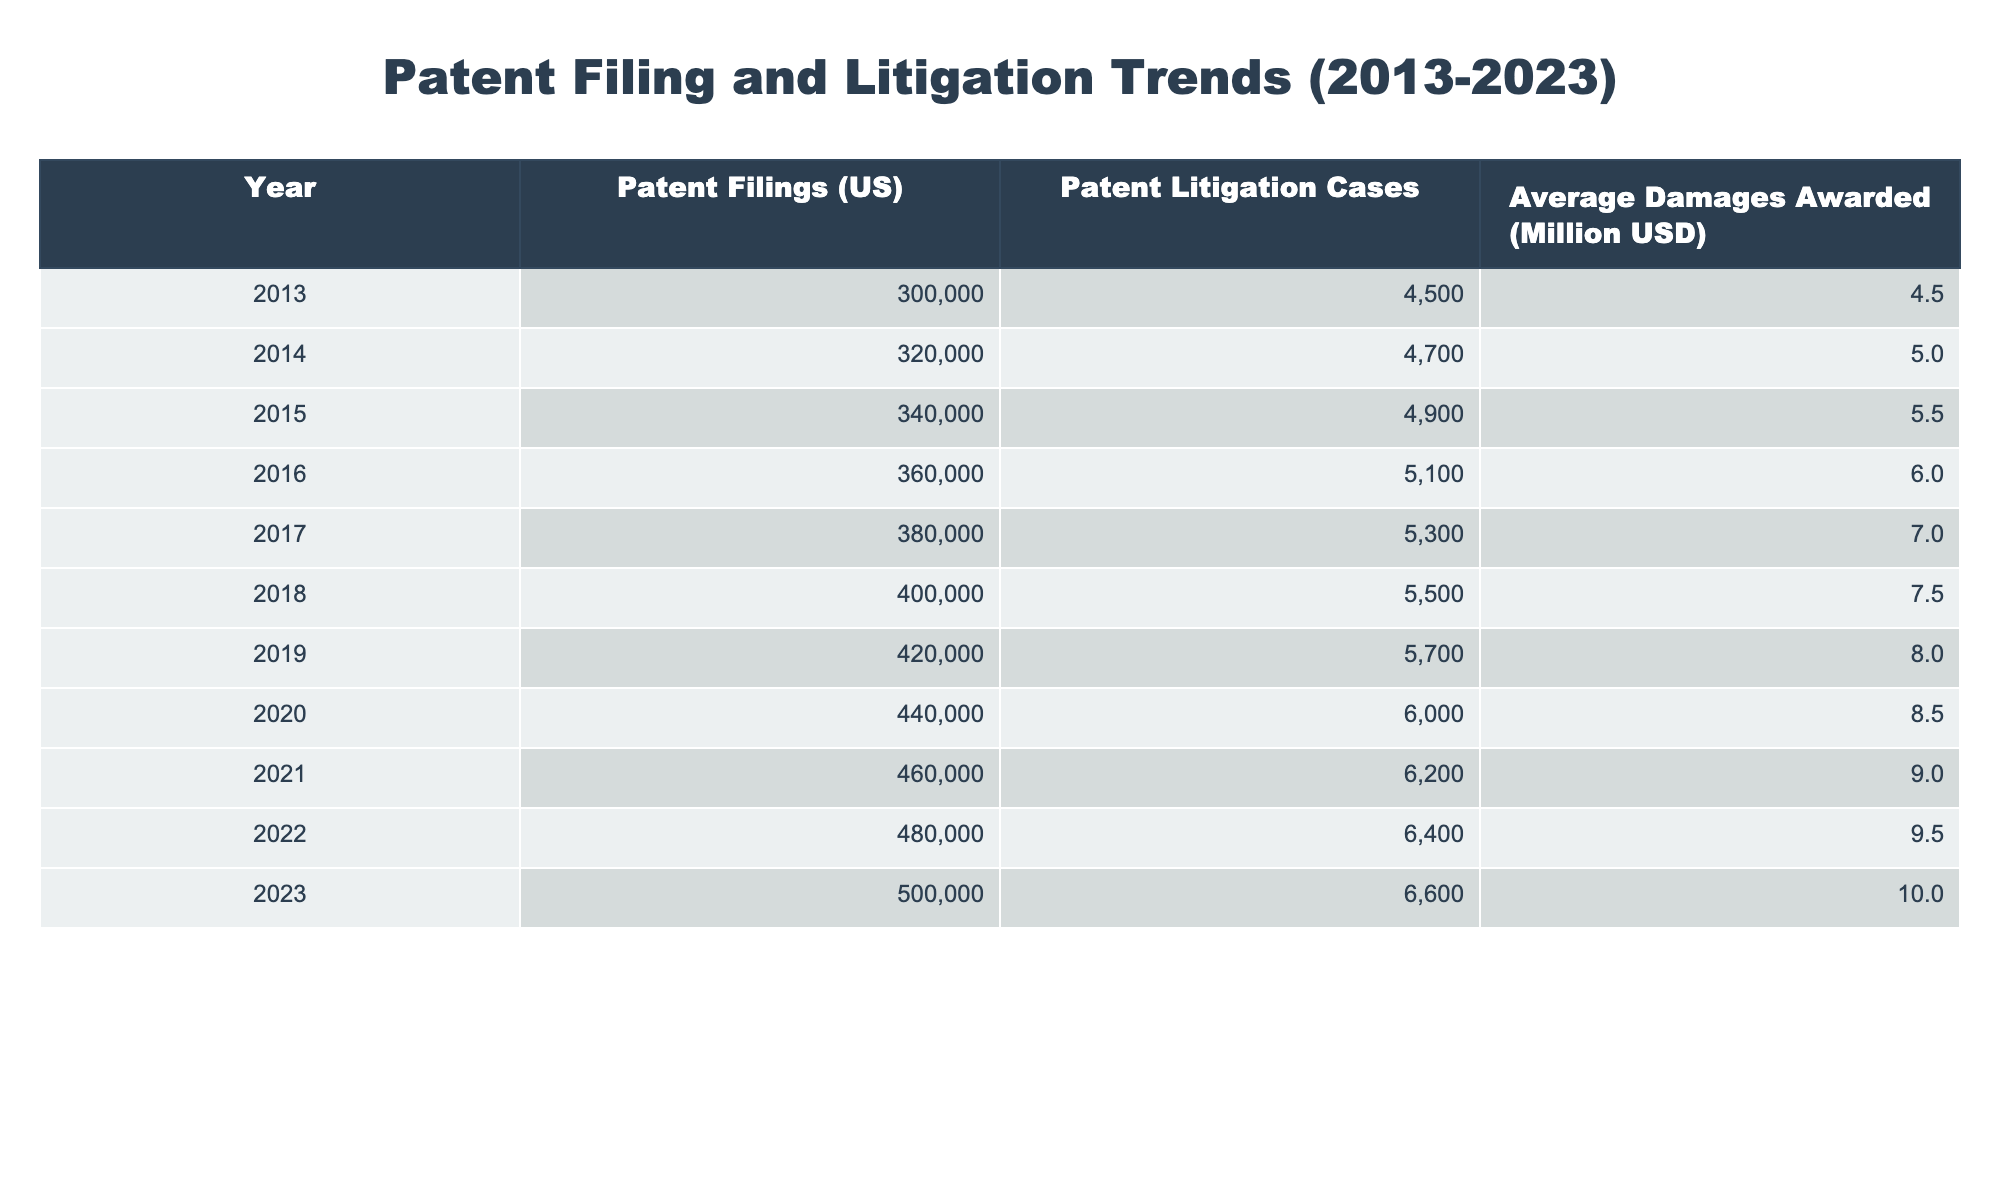What year saw the highest number of patent filings? By looking at the table, the 'Patent Filings (US)' column shows the values for each year. The highest value is 500,000 in the year 2023.
Answer: 2023 What was the average damages awarded in 2018? The table provides the 'Average Damages Awarded' for the year 2018 directly, which is listed as 7.5 million USD.
Answer: 7.5 million USD How many more patent litigation cases were there in 2020 compared to 2015? In 2020, there were 6,000 litigation cases, and in 2015, there were 4,900 cases. The difference is calculated as 6,000 - 4,900 = 1,100.
Answer: 1,100 Did the average damages awarded increase every year? The table shows a consistent increase in the 'Average Damages Awarded' from 4.5 million USD in 2013 to 10 million USD in 2023, indicating a yearly increase.
Answer: Yes What was the total number of patent filings from 2013 to 2022? To find the total, add the number of patent filings for each year from 2013 (300,000) to 2022 (480,000). The total is 300,000 + 320,000 + 340,000 + 360,000 + 380,000 + 400,000 + 420,000 + 440,000 + 460,000 + 480,000 =  3,460,000.
Answer: 3,460,000 What is the average number of patent litigation cases from 2013 to 2023? The sum of patent litigation cases from each year is 4500 + 4700 + 4900 + 5100 + 5300 + 5500 + 5700 + 6000 + 6200 + 6400 + 6600 =  56,600. There are 11 years, so the average is 56,600 / 11 = 5,145.45.
Answer: Approximately 5,145 Which year had the largest increase in the average damages awarded? To find this, look at the differences in 'Average Damages Awarded' between consecutive years. The largest increase was from 9.5 million USD in 2022 to 10 million USD in 2023, which is an increase of 0.5 million USD.
Answer: 2022 to 2023 How many total patent litigation cases occurred in the years with filings above 400,000? The years with filings over 400,000 are 2018 (5,500), 2019 (5,700), 2020 (6,000), 2021 (6,200), 2022 (6,400), and 2023 (6,600). The total is 5,500 + 5,700 + 6,000 + 6,200 + 6,400 + 6,600 = 36,400.
Answer: 36,400 Was the number of patent filings in 2015 higher than in 2012? The data for 2012 is not present in the table, so we cannot compare, making it impossible to determine.
Answer: No (data not available) 